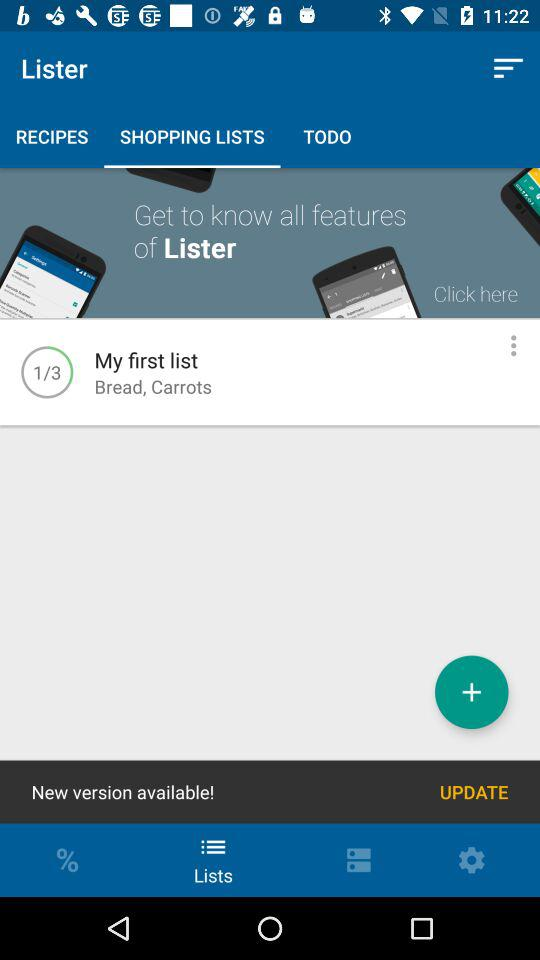What's on the "My first list"? The "My first list" contains bread and carrots. 